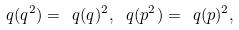<formula> <loc_0><loc_0><loc_500><loc_500>\ q ( q ^ { 2 } ) = \ q ( q ) ^ { 2 } , \, \ q ( p ^ { 2 } ) = \ q ( p ) ^ { 2 } ,</formula> 